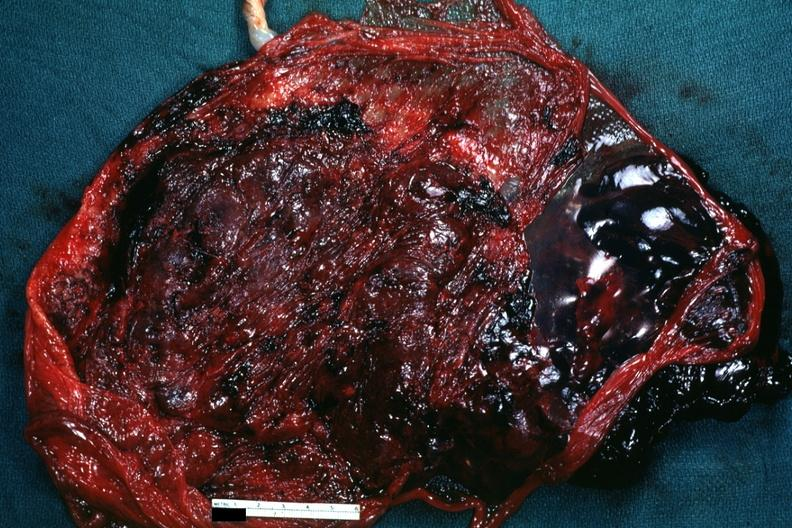what is present?
Answer the question using a single word or phrase. Placenta 